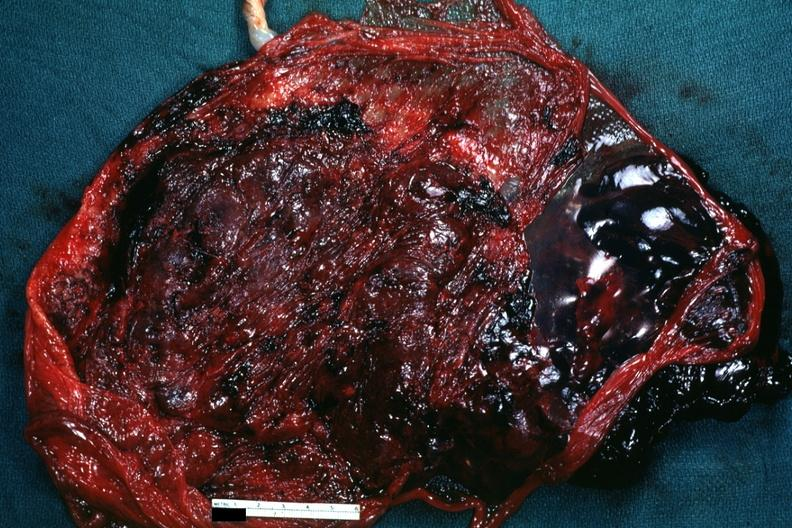what is present?
Answer the question using a single word or phrase. Placenta 